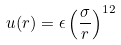Convert formula to latex. <formula><loc_0><loc_0><loc_500><loc_500>u ( r ) = \epsilon \left ( \frac { \sigma } { r } \right ) ^ { 1 2 }</formula> 